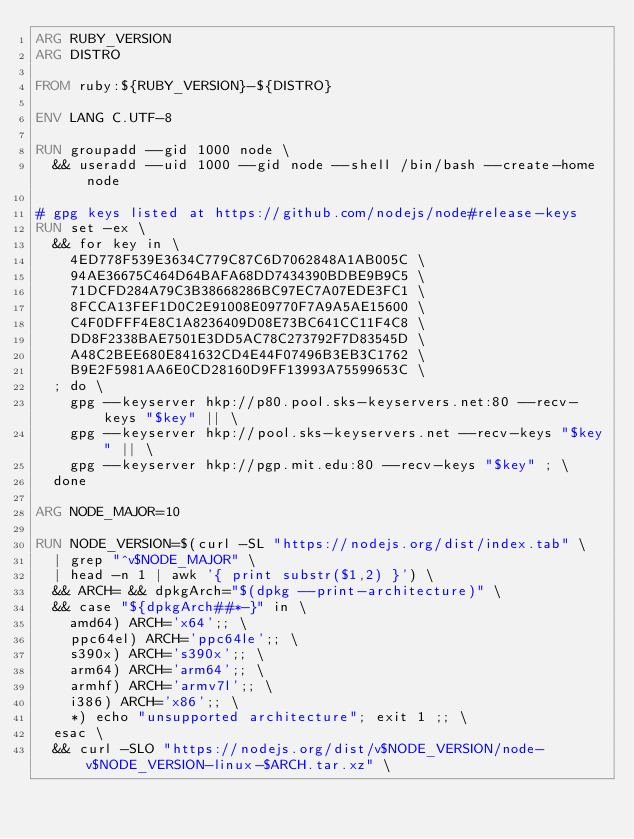Convert code to text. <code><loc_0><loc_0><loc_500><loc_500><_Dockerfile_>ARG RUBY_VERSION
ARG DISTRO

FROM ruby:${RUBY_VERSION}-${DISTRO}

ENV LANG C.UTF-8

RUN groupadd --gid 1000 node \
  && useradd --uid 1000 --gid node --shell /bin/bash --create-home node

# gpg keys listed at https://github.com/nodejs/node#release-keys
RUN set -ex \
  && for key in \
    4ED778F539E3634C779C87C6D7062848A1AB005C \
    94AE36675C464D64BAFA68DD7434390BDBE9B9C5 \
    71DCFD284A79C3B38668286BC97EC7A07EDE3FC1 \
    8FCCA13FEF1D0C2E91008E09770F7A9A5AE15600 \
    C4F0DFFF4E8C1A8236409D08E73BC641CC11F4C8 \
    DD8F2338BAE7501E3DD5AC78C273792F7D83545D \
    A48C2BEE680E841632CD4E44F07496B3EB3C1762 \
    B9E2F5981AA6E0CD28160D9FF13993A75599653C \
  ; do \
    gpg --keyserver hkp://p80.pool.sks-keyservers.net:80 --recv-keys "$key" || \
    gpg --keyserver hkp://pool.sks-keyservers.net --recv-keys "$key" || \
    gpg --keyserver hkp://pgp.mit.edu:80 --recv-keys "$key" ; \
  done

ARG NODE_MAJOR=10

RUN NODE_VERSION=$(curl -SL "https://nodejs.org/dist/index.tab" \
  | grep "^v$NODE_MAJOR" \
  | head -n 1 | awk '{ print substr($1,2) }') \
  && ARCH= && dpkgArch="$(dpkg --print-architecture)" \
  && case "${dpkgArch##*-}" in \
    amd64) ARCH='x64';; \
    ppc64el) ARCH='ppc64le';; \
    s390x) ARCH='s390x';; \
    arm64) ARCH='arm64';; \
    armhf) ARCH='armv7l';; \
    i386) ARCH='x86';; \
    *) echo "unsupported architecture"; exit 1 ;; \
  esac \
  && curl -SLO "https://nodejs.org/dist/v$NODE_VERSION/node-v$NODE_VERSION-linux-$ARCH.tar.xz" \</code> 